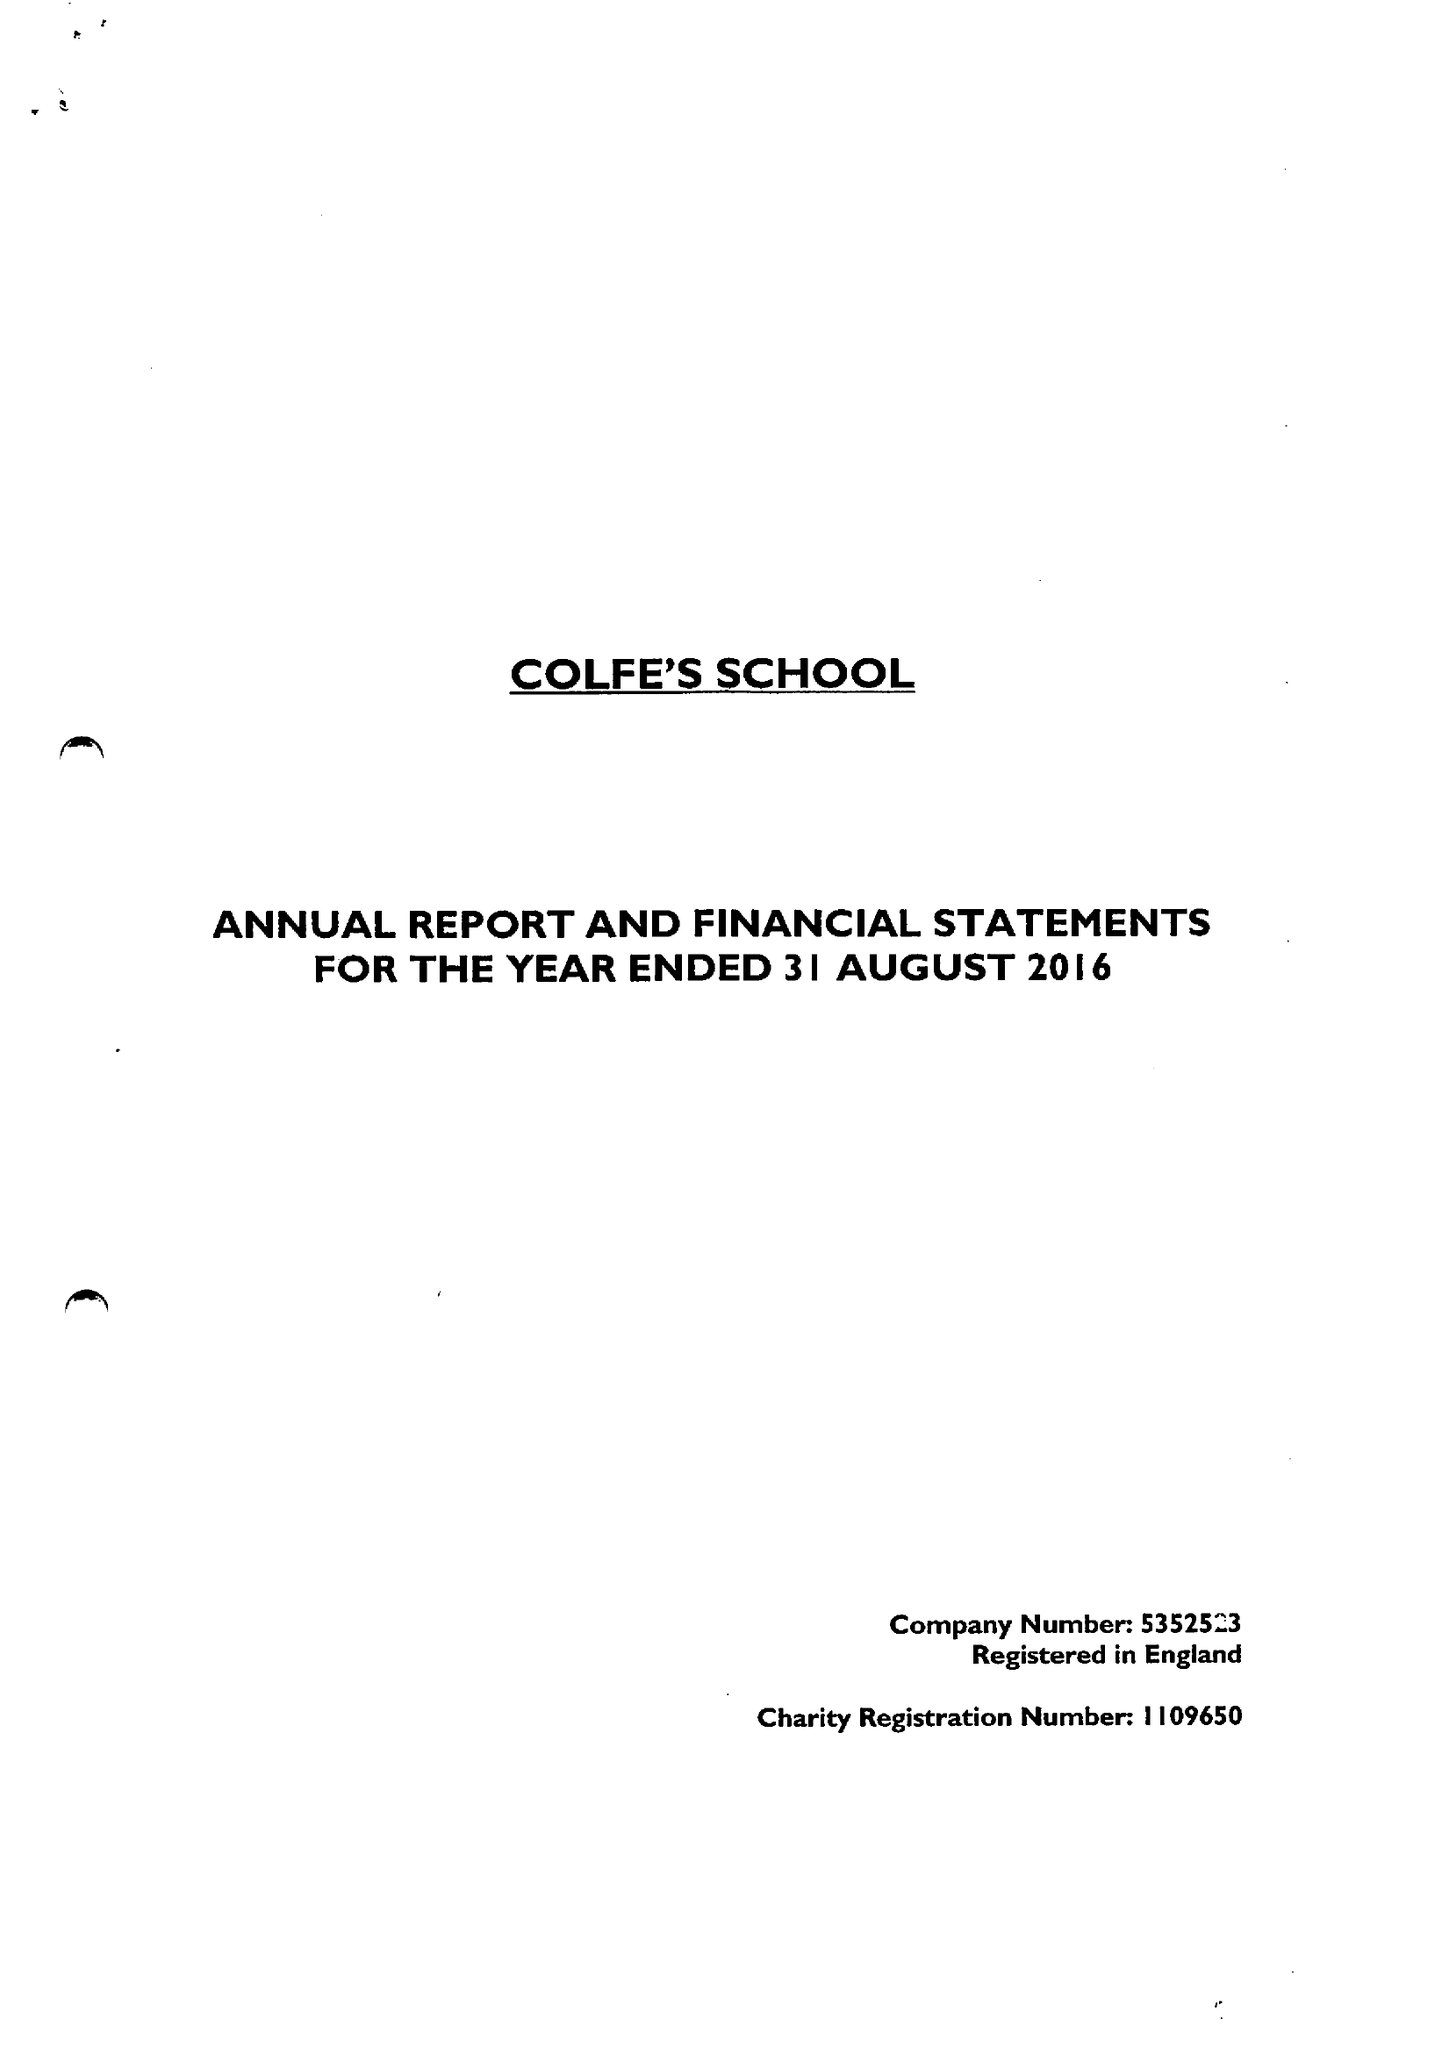What is the value for the address__post_town?
Answer the question using a single word or phrase. LONDON 